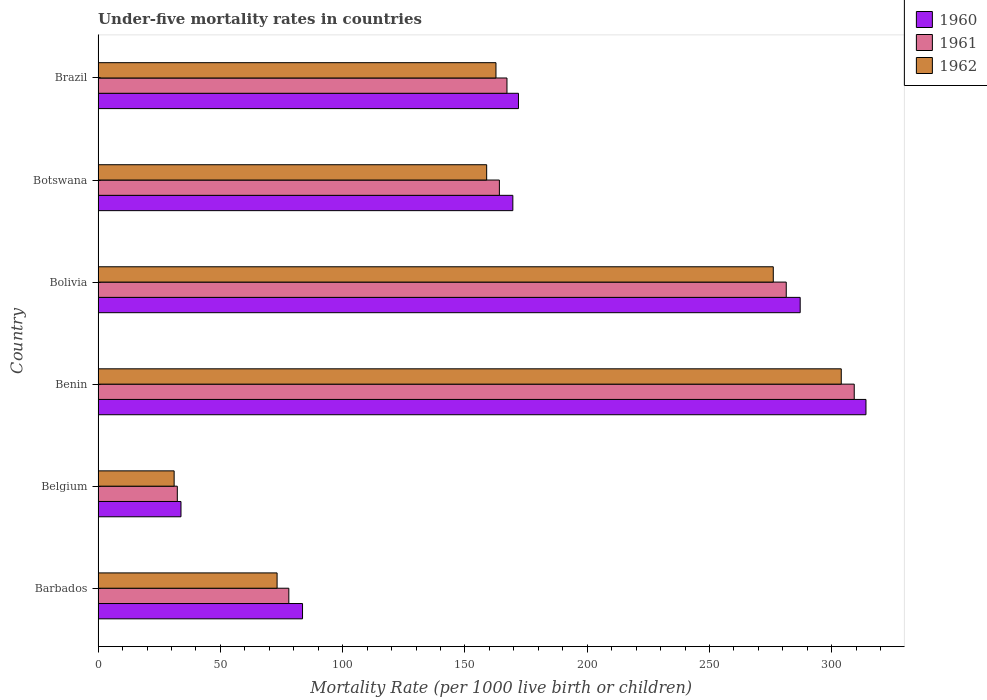How many groups of bars are there?
Keep it short and to the point. 6. How many bars are there on the 6th tick from the top?
Ensure brevity in your answer.  3. In how many cases, is the number of bars for a given country not equal to the number of legend labels?
Provide a succinct answer. 0. What is the under-five mortality rate in 1961 in Belgium?
Ensure brevity in your answer.  32.4. Across all countries, what is the maximum under-five mortality rate in 1962?
Your answer should be very brief. 303.9. Across all countries, what is the minimum under-five mortality rate in 1960?
Offer a terse response. 33.9. In which country was the under-five mortality rate in 1961 maximum?
Make the answer very short. Benin. In which country was the under-five mortality rate in 1960 minimum?
Provide a short and direct response. Belgium. What is the total under-five mortality rate in 1960 in the graph?
Give a very brief answer. 1060.1. What is the difference between the under-five mortality rate in 1960 in Belgium and that in Benin?
Keep it short and to the point. -280.1. What is the difference between the under-five mortality rate in 1961 in Bolivia and the under-five mortality rate in 1960 in Benin?
Keep it short and to the point. -32.6. What is the average under-five mortality rate in 1962 per country?
Provide a short and direct response. 167.65. What is the difference between the under-five mortality rate in 1961 and under-five mortality rate in 1960 in Brazil?
Provide a short and direct response. -4.7. What is the ratio of the under-five mortality rate in 1962 in Belgium to that in Bolivia?
Keep it short and to the point. 0.11. Is the under-five mortality rate in 1962 in Botswana less than that in Brazil?
Make the answer very short. Yes. What is the difference between the highest and the second highest under-five mortality rate in 1961?
Provide a succinct answer. 27.8. What is the difference between the highest and the lowest under-five mortality rate in 1960?
Keep it short and to the point. 280.1. In how many countries, is the under-five mortality rate in 1961 greater than the average under-five mortality rate in 1961 taken over all countries?
Your answer should be very brief. 2. Is it the case that in every country, the sum of the under-five mortality rate in 1960 and under-five mortality rate in 1962 is greater than the under-five mortality rate in 1961?
Keep it short and to the point. Yes. What is the difference between two consecutive major ticks on the X-axis?
Give a very brief answer. 50. Are the values on the major ticks of X-axis written in scientific E-notation?
Offer a very short reply. No. Does the graph contain any zero values?
Provide a short and direct response. No. Does the graph contain grids?
Ensure brevity in your answer.  No. How are the legend labels stacked?
Make the answer very short. Vertical. What is the title of the graph?
Ensure brevity in your answer.  Under-five mortality rates in countries. What is the label or title of the X-axis?
Your response must be concise. Mortality Rate (per 1000 live birth or children). What is the Mortality Rate (per 1000 live birth or children) in 1960 in Barbados?
Offer a very short reply. 83.6. What is the Mortality Rate (per 1000 live birth or children) of 1962 in Barbados?
Provide a short and direct response. 73.2. What is the Mortality Rate (per 1000 live birth or children) in 1960 in Belgium?
Give a very brief answer. 33.9. What is the Mortality Rate (per 1000 live birth or children) in 1961 in Belgium?
Provide a short and direct response. 32.4. What is the Mortality Rate (per 1000 live birth or children) in 1962 in Belgium?
Your response must be concise. 31.1. What is the Mortality Rate (per 1000 live birth or children) of 1960 in Benin?
Offer a very short reply. 314. What is the Mortality Rate (per 1000 live birth or children) in 1961 in Benin?
Make the answer very short. 309.2. What is the Mortality Rate (per 1000 live birth or children) of 1962 in Benin?
Offer a terse response. 303.9. What is the Mortality Rate (per 1000 live birth or children) of 1960 in Bolivia?
Make the answer very short. 287.1. What is the Mortality Rate (per 1000 live birth or children) in 1961 in Bolivia?
Provide a succinct answer. 281.4. What is the Mortality Rate (per 1000 live birth or children) of 1962 in Bolivia?
Ensure brevity in your answer.  276.1. What is the Mortality Rate (per 1000 live birth or children) in 1960 in Botswana?
Your response must be concise. 169.6. What is the Mortality Rate (per 1000 live birth or children) of 1961 in Botswana?
Your response must be concise. 164.1. What is the Mortality Rate (per 1000 live birth or children) of 1962 in Botswana?
Offer a very short reply. 158.9. What is the Mortality Rate (per 1000 live birth or children) in 1960 in Brazil?
Ensure brevity in your answer.  171.9. What is the Mortality Rate (per 1000 live birth or children) of 1961 in Brazil?
Give a very brief answer. 167.2. What is the Mortality Rate (per 1000 live birth or children) of 1962 in Brazil?
Offer a very short reply. 162.7. Across all countries, what is the maximum Mortality Rate (per 1000 live birth or children) in 1960?
Keep it short and to the point. 314. Across all countries, what is the maximum Mortality Rate (per 1000 live birth or children) of 1961?
Offer a terse response. 309.2. Across all countries, what is the maximum Mortality Rate (per 1000 live birth or children) in 1962?
Give a very brief answer. 303.9. Across all countries, what is the minimum Mortality Rate (per 1000 live birth or children) of 1960?
Offer a terse response. 33.9. Across all countries, what is the minimum Mortality Rate (per 1000 live birth or children) in 1961?
Provide a succinct answer. 32.4. Across all countries, what is the minimum Mortality Rate (per 1000 live birth or children) of 1962?
Keep it short and to the point. 31.1. What is the total Mortality Rate (per 1000 live birth or children) of 1960 in the graph?
Your response must be concise. 1060.1. What is the total Mortality Rate (per 1000 live birth or children) in 1961 in the graph?
Your response must be concise. 1032.3. What is the total Mortality Rate (per 1000 live birth or children) in 1962 in the graph?
Offer a very short reply. 1005.9. What is the difference between the Mortality Rate (per 1000 live birth or children) in 1960 in Barbados and that in Belgium?
Offer a very short reply. 49.7. What is the difference between the Mortality Rate (per 1000 live birth or children) of 1961 in Barbados and that in Belgium?
Provide a short and direct response. 45.6. What is the difference between the Mortality Rate (per 1000 live birth or children) in 1962 in Barbados and that in Belgium?
Make the answer very short. 42.1. What is the difference between the Mortality Rate (per 1000 live birth or children) of 1960 in Barbados and that in Benin?
Keep it short and to the point. -230.4. What is the difference between the Mortality Rate (per 1000 live birth or children) in 1961 in Barbados and that in Benin?
Provide a succinct answer. -231.2. What is the difference between the Mortality Rate (per 1000 live birth or children) of 1962 in Barbados and that in Benin?
Offer a very short reply. -230.7. What is the difference between the Mortality Rate (per 1000 live birth or children) of 1960 in Barbados and that in Bolivia?
Offer a very short reply. -203.5. What is the difference between the Mortality Rate (per 1000 live birth or children) in 1961 in Barbados and that in Bolivia?
Give a very brief answer. -203.4. What is the difference between the Mortality Rate (per 1000 live birth or children) in 1962 in Barbados and that in Bolivia?
Keep it short and to the point. -202.9. What is the difference between the Mortality Rate (per 1000 live birth or children) of 1960 in Barbados and that in Botswana?
Your response must be concise. -86. What is the difference between the Mortality Rate (per 1000 live birth or children) of 1961 in Barbados and that in Botswana?
Your answer should be very brief. -86.1. What is the difference between the Mortality Rate (per 1000 live birth or children) in 1962 in Barbados and that in Botswana?
Your answer should be compact. -85.7. What is the difference between the Mortality Rate (per 1000 live birth or children) of 1960 in Barbados and that in Brazil?
Your answer should be compact. -88.3. What is the difference between the Mortality Rate (per 1000 live birth or children) in 1961 in Barbados and that in Brazil?
Make the answer very short. -89.2. What is the difference between the Mortality Rate (per 1000 live birth or children) of 1962 in Barbados and that in Brazil?
Provide a succinct answer. -89.5. What is the difference between the Mortality Rate (per 1000 live birth or children) in 1960 in Belgium and that in Benin?
Give a very brief answer. -280.1. What is the difference between the Mortality Rate (per 1000 live birth or children) in 1961 in Belgium and that in Benin?
Provide a short and direct response. -276.8. What is the difference between the Mortality Rate (per 1000 live birth or children) in 1962 in Belgium and that in Benin?
Make the answer very short. -272.8. What is the difference between the Mortality Rate (per 1000 live birth or children) in 1960 in Belgium and that in Bolivia?
Offer a terse response. -253.2. What is the difference between the Mortality Rate (per 1000 live birth or children) in 1961 in Belgium and that in Bolivia?
Offer a very short reply. -249. What is the difference between the Mortality Rate (per 1000 live birth or children) in 1962 in Belgium and that in Bolivia?
Your response must be concise. -245. What is the difference between the Mortality Rate (per 1000 live birth or children) of 1960 in Belgium and that in Botswana?
Keep it short and to the point. -135.7. What is the difference between the Mortality Rate (per 1000 live birth or children) of 1961 in Belgium and that in Botswana?
Make the answer very short. -131.7. What is the difference between the Mortality Rate (per 1000 live birth or children) in 1962 in Belgium and that in Botswana?
Ensure brevity in your answer.  -127.8. What is the difference between the Mortality Rate (per 1000 live birth or children) of 1960 in Belgium and that in Brazil?
Keep it short and to the point. -138. What is the difference between the Mortality Rate (per 1000 live birth or children) of 1961 in Belgium and that in Brazil?
Your answer should be very brief. -134.8. What is the difference between the Mortality Rate (per 1000 live birth or children) in 1962 in Belgium and that in Brazil?
Offer a very short reply. -131.6. What is the difference between the Mortality Rate (per 1000 live birth or children) in 1960 in Benin and that in Bolivia?
Your response must be concise. 26.9. What is the difference between the Mortality Rate (per 1000 live birth or children) in 1961 in Benin and that in Bolivia?
Keep it short and to the point. 27.8. What is the difference between the Mortality Rate (per 1000 live birth or children) in 1962 in Benin and that in Bolivia?
Give a very brief answer. 27.8. What is the difference between the Mortality Rate (per 1000 live birth or children) of 1960 in Benin and that in Botswana?
Offer a very short reply. 144.4. What is the difference between the Mortality Rate (per 1000 live birth or children) in 1961 in Benin and that in Botswana?
Provide a succinct answer. 145.1. What is the difference between the Mortality Rate (per 1000 live birth or children) of 1962 in Benin and that in Botswana?
Your response must be concise. 145. What is the difference between the Mortality Rate (per 1000 live birth or children) in 1960 in Benin and that in Brazil?
Your answer should be compact. 142.1. What is the difference between the Mortality Rate (per 1000 live birth or children) of 1961 in Benin and that in Brazil?
Your answer should be very brief. 142. What is the difference between the Mortality Rate (per 1000 live birth or children) in 1962 in Benin and that in Brazil?
Keep it short and to the point. 141.2. What is the difference between the Mortality Rate (per 1000 live birth or children) in 1960 in Bolivia and that in Botswana?
Ensure brevity in your answer.  117.5. What is the difference between the Mortality Rate (per 1000 live birth or children) of 1961 in Bolivia and that in Botswana?
Your answer should be very brief. 117.3. What is the difference between the Mortality Rate (per 1000 live birth or children) of 1962 in Bolivia and that in Botswana?
Your response must be concise. 117.2. What is the difference between the Mortality Rate (per 1000 live birth or children) of 1960 in Bolivia and that in Brazil?
Make the answer very short. 115.2. What is the difference between the Mortality Rate (per 1000 live birth or children) of 1961 in Bolivia and that in Brazil?
Make the answer very short. 114.2. What is the difference between the Mortality Rate (per 1000 live birth or children) of 1962 in Bolivia and that in Brazil?
Make the answer very short. 113.4. What is the difference between the Mortality Rate (per 1000 live birth or children) of 1960 in Botswana and that in Brazil?
Provide a short and direct response. -2.3. What is the difference between the Mortality Rate (per 1000 live birth or children) of 1962 in Botswana and that in Brazil?
Keep it short and to the point. -3.8. What is the difference between the Mortality Rate (per 1000 live birth or children) in 1960 in Barbados and the Mortality Rate (per 1000 live birth or children) in 1961 in Belgium?
Your answer should be compact. 51.2. What is the difference between the Mortality Rate (per 1000 live birth or children) in 1960 in Barbados and the Mortality Rate (per 1000 live birth or children) in 1962 in Belgium?
Provide a succinct answer. 52.5. What is the difference between the Mortality Rate (per 1000 live birth or children) in 1961 in Barbados and the Mortality Rate (per 1000 live birth or children) in 1962 in Belgium?
Keep it short and to the point. 46.9. What is the difference between the Mortality Rate (per 1000 live birth or children) in 1960 in Barbados and the Mortality Rate (per 1000 live birth or children) in 1961 in Benin?
Your response must be concise. -225.6. What is the difference between the Mortality Rate (per 1000 live birth or children) of 1960 in Barbados and the Mortality Rate (per 1000 live birth or children) of 1962 in Benin?
Offer a very short reply. -220.3. What is the difference between the Mortality Rate (per 1000 live birth or children) of 1961 in Barbados and the Mortality Rate (per 1000 live birth or children) of 1962 in Benin?
Give a very brief answer. -225.9. What is the difference between the Mortality Rate (per 1000 live birth or children) in 1960 in Barbados and the Mortality Rate (per 1000 live birth or children) in 1961 in Bolivia?
Your response must be concise. -197.8. What is the difference between the Mortality Rate (per 1000 live birth or children) in 1960 in Barbados and the Mortality Rate (per 1000 live birth or children) in 1962 in Bolivia?
Your response must be concise. -192.5. What is the difference between the Mortality Rate (per 1000 live birth or children) in 1961 in Barbados and the Mortality Rate (per 1000 live birth or children) in 1962 in Bolivia?
Ensure brevity in your answer.  -198.1. What is the difference between the Mortality Rate (per 1000 live birth or children) in 1960 in Barbados and the Mortality Rate (per 1000 live birth or children) in 1961 in Botswana?
Provide a short and direct response. -80.5. What is the difference between the Mortality Rate (per 1000 live birth or children) in 1960 in Barbados and the Mortality Rate (per 1000 live birth or children) in 1962 in Botswana?
Provide a succinct answer. -75.3. What is the difference between the Mortality Rate (per 1000 live birth or children) in 1961 in Barbados and the Mortality Rate (per 1000 live birth or children) in 1962 in Botswana?
Make the answer very short. -80.9. What is the difference between the Mortality Rate (per 1000 live birth or children) of 1960 in Barbados and the Mortality Rate (per 1000 live birth or children) of 1961 in Brazil?
Provide a succinct answer. -83.6. What is the difference between the Mortality Rate (per 1000 live birth or children) of 1960 in Barbados and the Mortality Rate (per 1000 live birth or children) of 1962 in Brazil?
Provide a short and direct response. -79.1. What is the difference between the Mortality Rate (per 1000 live birth or children) of 1961 in Barbados and the Mortality Rate (per 1000 live birth or children) of 1962 in Brazil?
Keep it short and to the point. -84.7. What is the difference between the Mortality Rate (per 1000 live birth or children) in 1960 in Belgium and the Mortality Rate (per 1000 live birth or children) in 1961 in Benin?
Offer a terse response. -275.3. What is the difference between the Mortality Rate (per 1000 live birth or children) of 1960 in Belgium and the Mortality Rate (per 1000 live birth or children) of 1962 in Benin?
Your response must be concise. -270. What is the difference between the Mortality Rate (per 1000 live birth or children) of 1961 in Belgium and the Mortality Rate (per 1000 live birth or children) of 1962 in Benin?
Give a very brief answer. -271.5. What is the difference between the Mortality Rate (per 1000 live birth or children) in 1960 in Belgium and the Mortality Rate (per 1000 live birth or children) in 1961 in Bolivia?
Provide a succinct answer. -247.5. What is the difference between the Mortality Rate (per 1000 live birth or children) of 1960 in Belgium and the Mortality Rate (per 1000 live birth or children) of 1962 in Bolivia?
Provide a short and direct response. -242.2. What is the difference between the Mortality Rate (per 1000 live birth or children) of 1961 in Belgium and the Mortality Rate (per 1000 live birth or children) of 1962 in Bolivia?
Provide a short and direct response. -243.7. What is the difference between the Mortality Rate (per 1000 live birth or children) of 1960 in Belgium and the Mortality Rate (per 1000 live birth or children) of 1961 in Botswana?
Keep it short and to the point. -130.2. What is the difference between the Mortality Rate (per 1000 live birth or children) in 1960 in Belgium and the Mortality Rate (per 1000 live birth or children) in 1962 in Botswana?
Make the answer very short. -125. What is the difference between the Mortality Rate (per 1000 live birth or children) in 1961 in Belgium and the Mortality Rate (per 1000 live birth or children) in 1962 in Botswana?
Ensure brevity in your answer.  -126.5. What is the difference between the Mortality Rate (per 1000 live birth or children) of 1960 in Belgium and the Mortality Rate (per 1000 live birth or children) of 1961 in Brazil?
Offer a very short reply. -133.3. What is the difference between the Mortality Rate (per 1000 live birth or children) in 1960 in Belgium and the Mortality Rate (per 1000 live birth or children) in 1962 in Brazil?
Make the answer very short. -128.8. What is the difference between the Mortality Rate (per 1000 live birth or children) in 1961 in Belgium and the Mortality Rate (per 1000 live birth or children) in 1962 in Brazil?
Give a very brief answer. -130.3. What is the difference between the Mortality Rate (per 1000 live birth or children) in 1960 in Benin and the Mortality Rate (per 1000 live birth or children) in 1961 in Bolivia?
Provide a succinct answer. 32.6. What is the difference between the Mortality Rate (per 1000 live birth or children) of 1960 in Benin and the Mortality Rate (per 1000 live birth or children) of 1962 in Bolivia?
Provide a succinct answer. 37.9. What is the difference between the Mortality Rate (per 1000 live birth or children) of 1961 in Benin and the Mortality Rate (per 1000 live birth or children) of 1962 in Bolivia?
Keep it short and to the point. 33.1. What is the difference between the Mortality Rate (per 1000 live birth or children) of 1960 in Benin and the Mortality Rate (per 1000 live birth or children) of 1961 in Botswana?
Give a very brief answer. 149.9. What is the difference between the Mortality Rate (per 1000 live birth or children) of 1960 in Benin and the Mortality Rate (per 1000 live birth or children) of 1962 in Botswana?
Ensure brevity in your answer.  155.1. What is the difference between the Mortality Rate (per 1000 live birth or children) in 1961 in Benin and the Mortality Rate (per 1000 live birth or children) in 1962 in Botswana?
Provide a short and direct response. 150.3. What is the difference between the Mortality Rate (per 1000 live birth or children) in 1960 in Benin and the Mortality Rate (per 1000 live birth or children) in 1961 in Brazil?
Provide a short and direct response. 146.8. What is the difference between the Mortality Rate (per 1000 live birth or children) of 1960 in Benin and the Mortality Rate (per 1000 live birth or children) of 1962 in Brazil?
Provide a succinct answer. 151.3. What is the difference between the Mortality Rate (per 1000 live birth or children) in 1961 in Benin and the Mortality Rate (per 1000 live birth or children) in 1962 in Brazil?
Offer a very short reply. 146.5. What is the difference between the Mortality Rate (per 1000 live birth or children) in 1960 in Bolivia and the Mortality Rate (per 1000 live birth or children) in 1961 in Botswana?
Offer a very short reply. 123. What is the difference between the Mortality Rate (per 1000 live birth or children) of 1960 in Bolivia and the Mortality Rate (per 1000 live birth or children) of 1962 in Botswana?
Make the answer very short. 128.2. What is the difference between the Mortality Rate (per 1000 live birth or children) in 1961 in Bolivia and the Mortality Rate (per 1000 live birth or children) in 1962 in Botswana?
Provide a short and direct response. 122.5. What is the difference between the Mortality Rate (per 1000 live birth or children) of 1960 in Bolivia and the Mortality Rate (per 1000 live birth or children) of 1961 in Brazil?
Give a very brief answer. 119.9. What is the difference between the Mortality Rate (per 1000 live birth or children) in 1960 in Bolivia and the Mortality Rate (per 1000 live birth or children) in 1962 in Brazil?
Your answer should be compact. 124.4. What is the difference between the Mortality Rate (per 1000 live birth or children) in 1961 in Bolivia and the Mortality Rate (per 1000 live birth or children) in 1962 in Brazil?
Provide a short and direct response. 118.7. What is the difference between the Mortality Rate (per 1000 live birth or children) of 1961 in Botswana and the Mortality Rate (per 1000 live birth or children) of 1962 in Brazil?
Your answer should be compact. 1.4. What is the average Mortality Rate (per 1000 live birth or children) of 1960 per country?
Your answer should be compact. 176.68. What is the average Mortality Rate (per 1000 live birth or children) of 1961 per country?
Offer a very short reply. 172.05. What is the average Mortality Rate (per 1000 live birth or children) of 1962 per country?
Offer a terse response. 167.65. What is the difference between the Mortality Rate (per 1000 live birth or children) in 1960 and Mortality Rate (per 1000 live birth or children) in 1961 in Barbados?
Make the answer very short. 5.6. What is the difference between the Mortality Rate (per 1000 live birth or children) in 1961 and Mortality Rate (per 1000 live birth or children) in 1962 in Barbados?
Make the answer very short. 4.8. What is the difference between the Mortality Rate (per 1000 live birth or children) of 1961 and Mortality Rate (per 1000 live birth or children) of 1962 in Belgium?
Your response must be concise. 1.3. What is the difference between the Mortality Rate (per 1000 live birth or children) in 1960 and Mortality Rate (per 1000 live birth or children) in 1961 in Bolivia?
Ensure brevity in your answer.  5.7. What is the difference between the Mortality Rate (per 1000 live birth or children) of 1960 and Mortality Rate (per 1000 live birth or children) of 1962 in Bolivia?
Make the answer very short. 11. What is the difference between the Mortality Rate (per 1000 live birth or children) in 1961 and Mortality Rate (per 1000 live birth or children) in 1962 in Bolivia?
Give a very brief answer. 5.3. What is the difference between the Mortality Rate (per 1000 live birth or children) in 1960 and Mortality Rate (per 1000 live birth or children) in 1961 in Brazil?
Keep it short and to the point. 4.7. What is the difference between the Mortality Rate (per 1000 live birth or children) in 1960 and Mortality Rate (per 1000 live birth or children) in 1962 in Brazil?
Make the answer very short. 9.2. What is the difference between the Mortality Rate (per 1000 live birth or children) in 1961 and Mortality Rate (per 1000 live birth or children) in 1962 in Brazil?
Give a very brief answer. 4.5. What is the ratio of the Mortality Rate (per 1000 live birth or children) in 1960 in Barbados to that in Belgium?
Make the answer very short. 2.47. What is the ratio of the Mortality Rate (per 1000 live birth or children) in 1961 in Barbados to that in Belgium?
Ensure brevity in your answer.  2.41. What is the ratio of the Mortality Rate (per 1000 live birth or children) in 1962 in Barbados to that in Belgium?
Ensure brevity in your answer.  2.35. What is the ratio of the Mortality Rate (per 1000 live birth or children) of 1960 in Barbados to that in Benin?
Offer a terse response. 0.27. What is the ratio of the Mortality Rate (per 1000 live birth or children) in 1961 in Barbados to that in Benin?
Provide a succinct answer. 0.25. What is the ratio of the Mortality Rate (per 1000 live birth or children) of 1962 in Barbados to that in Benin?
Your answer should be very brief. 0.24. What is the ratio of the Mortality Rate (per 1000 live birth or children) in 1960 in Barbados to that in Bolivia?
Give a very brief answer. 0.29. What is the ratio of the Mortality Rate (per 1000 live birth or children) of 1961 in Barbados to that in Bolivia?
Offer a terse response. 0.28. What is the ratio of the Mortality Rate (per 1000 live birth or children) in 1962 in Barbados to that in Bolivia?
Provide a short and direct response. 0.27. What is the ratio of the Mortality Rate (per 1000 live birth or children) in 1960 in Barbados to that in Botswana?
Give a very brief answer. 0.49. What is the ratio of the Mortality Rate (per 1000 live birth or children) of 1961 in Barbados to that in Botswana?
Your answer should be very brief. 0.48. What is the ratio of the Mortality Rate (per 1000 live birth or children) in 1962 in Barbados to that in Botswana?
Offer a terse response. 0.46. What is the ratio of the Mortality Rate (per 1000 live birth or children) in 1960 in Barbados to that in Brazil?
Your response must be concise. 0.49. What is the ratio of the Mortality Rate (per 1000 live birth or children) in 1961 in Barbados to that in Brazil?
Your answer should be very brief. 0.47. What is the ratio of the Mortality Rate (per 1000 live birth or children) of 1962 in Barbados to that in Brazil?
Give a very brief answer. 0.45. What is the ratio of the Mortality Rate (per 1000 live birth or children) of 1960 in Belgium to that in Benin?
Give a very brief answer. 0.11. What is the ratio of the Mortality Rate (per 1000 live birth or children) in 1961 in Belgium to that in Benin?
Your answer should be compact. 0.1. What is the ratio of the Mortality Rate (per 1000 live birth or children) of 1962 in Belgium to that in Benin?
Your response must be concise. 0.1. What is the ratio of the Mortality Rate (per 1000 live birth or children) in 1960 in Belgium to that in Bolivia?
Your answer should be compact. 0.12. What is the ratio of the Mortality Rate (per 1000 live birth or children) in 1961 in Belgium to that in Bolivia?
Keep it short and to the point. 0.12. What is the ratio of the Mortality Rate (per 1000 live birth or children) in 1962 in Belgium to that in Bolivia?
Provide a short and direct response. 0.11. What is the ratio of the Mortality Rate (per 1000 live birth or children) of 1960 in Belgium to that in Botswana?
Provide a succinct answer. 0.2. What is the ratio of the Mortality Rate (per 1000 live birth or children) in 1961 in Belgium to that in Botswana?
Offer a terse response. 0.2. What is the ratio of the Mortality Rate (per 1000 live birth or children) of 1962 in Belgium to that in Botswana?
Keep it short and to the point. 0.2. What is the ratio of the Mortality Rate (per 1000 live birth or children) of 1960 in Belgium to that in Brazil?
Your answer should be compact. 0.2. What is the ratio of the Mortality Rate (per 1000 live birth or children) in 1961 in Belgium to that in Brazil?
Offer a terse response. 0.19. What is the ratio of the Mortality Rate (per 1000 live birth or children) in 1962 in Belgium to that in Brazil?
Offer a terse response. 0.19. What is the ratio of the Mortality Rate (per 1000 live birth or children) in 1960 in Benin to that in Bolivia?
Provide a succinct answer. 1.09. What is the ratio of the Mortality Rate (per 1000 live birth or children) in 1961 in Benin to that in Bolivia?
Your answer should be compact. 1.1. What is the ratio of the Mortality Rate (per 1000 live birth or children) in 1962 in Benin to that in Bolivia?
Ensure brevity in your answer.  1.1. What is the ratio of the Mortality Rate (per 1000 live birth or children) in 1960 in Benin to that in Botswana?
Provide a succinct answer. 1.85. What is the ratio of the Mortality Rate (per 1000 live birth or children) in 1961 in Benin to that in Botswana?
Your answer should be very brief. 1.88. What is the ratio of the Mortality Rate (per 1000 live birth or children) in 1962 in Benin to that in Botswana?
Make the answer very short. 1.91. What is the ratio of the Mortality Rate (per 1000 live birth or children) in 1960 in Benin to that in Brazil?
Provide a short and direct response. 1.83. What is the ratio of the Mortality Rate (per 1000 live birth or children) in 1961 in Benin to that in Brazil?
Make the answer very short. 1.85. What is the ratio of the Mortality Rate (per 1000 live birth or children) in 1962 in Benin to that in Brazil?
Give a very brief answer. 1.87. What is the ratio of the Mortality Rate (per 1000 live birth or children) of 1960 in Bolivia to that in Botswana?
Offer a terse response. 1.69. What is the ratio of the Mortality Rate (per 1000 live birth or children) of 1961 in Bolivia to that in Botswana?
Make the answer very short. 1.71. What is the ratio of the Mortality Rate (per 1000 live birth or children) in 1962 in Bolivia to that in Botswana?
Ensure brevity in your answer.  1.74. What is the ratio of the Mortality Rate (per 1000 live birth or children) in 1960 in Bolivia to that in Brazil?
Offer a terse response. 1.67. What is the ratio of the Mortality Rate (per 1000 live birth or children) of 1961 in Bolivia to that in Brazil?
Provide a short and direct response. 1.68. What is the ratio of the Mortality Rate (per 1000 live birth or children) of 1962 in Bolivia to that in Brazil?
Provide a short and direct response. 1.7. What is the ratio of the Mortality Rate (per 1000 live birth or children) in 1960 in Botswana to that in Brazil?
Offer a terse response. 0.99. What is the ratio of the Mortality Rate (per 1000 live birth or children) in 1961 in Botswana to that in Brazil?
Keep it short and to the point. 0.98. What is the ratio of the Mortality Rate (per 1000 live birth or children) in 1962 in Botswana to that in Brazil?
Your response must be concise. 0.98. What is the difference between the highest and the second highest Mortality Rate (per 1000 live birth or children) of 1960?
Provide a succinct answer. 26.9. What is the difference between the highest and the second highest Mortality Rate (per 1000 live birth or children) of 1961?
Your answer should be very brief. 27.8. What is the difference between the highest and the second highest Mortality Rate (per 1000 live birth or children) in 1962?
Ensure brevity in your answer.  27.8. What is the difference between the highest and the lowest Mortality Rate (per 1000 live birth or children) of 1960?
Provide a short and direct response. 280.1. What is the difference between the highest and the lowest Mortality Rate (per 1000 live birth or children) in 1961?
Offer a terse response. 276.8. What is the difference between the highest and the lowest Mortality Rate (per 1000 live birth or children) of 1962?
Keep it short and to the point. 272.8. 